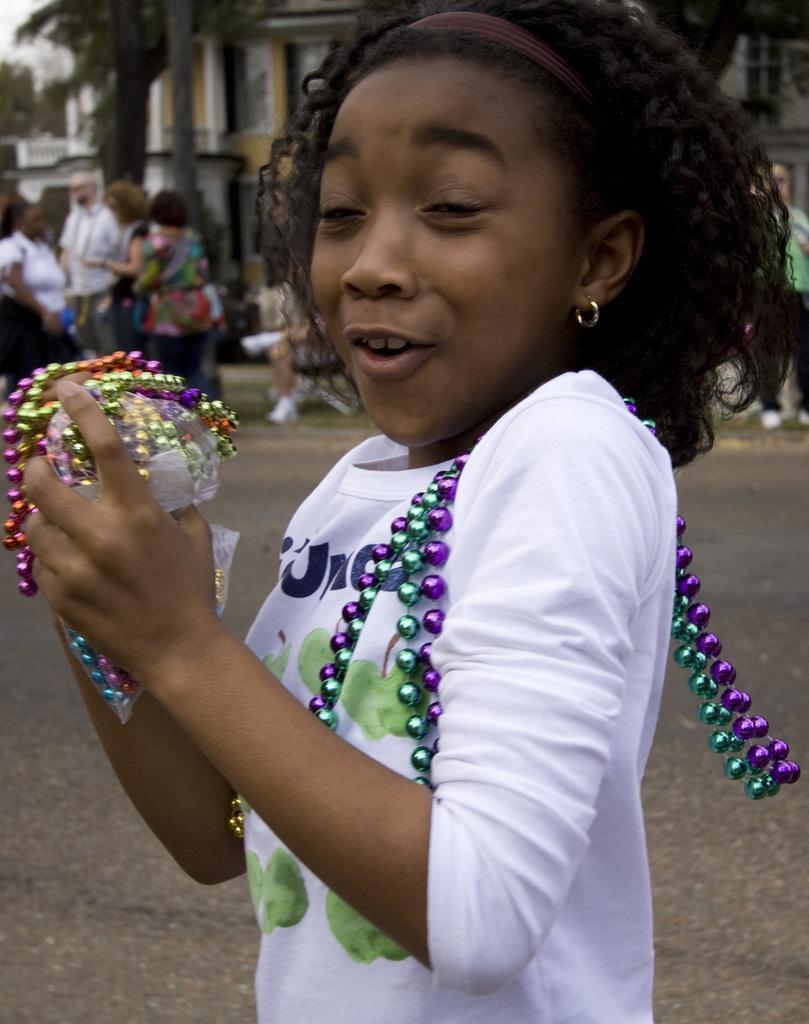Can you describe this image briefly? In this image we can see a girl and she is smiling. Here we can see the bead chains in her hands. Here we can see a few people on the left side. In the background, we can see the building and trees. 